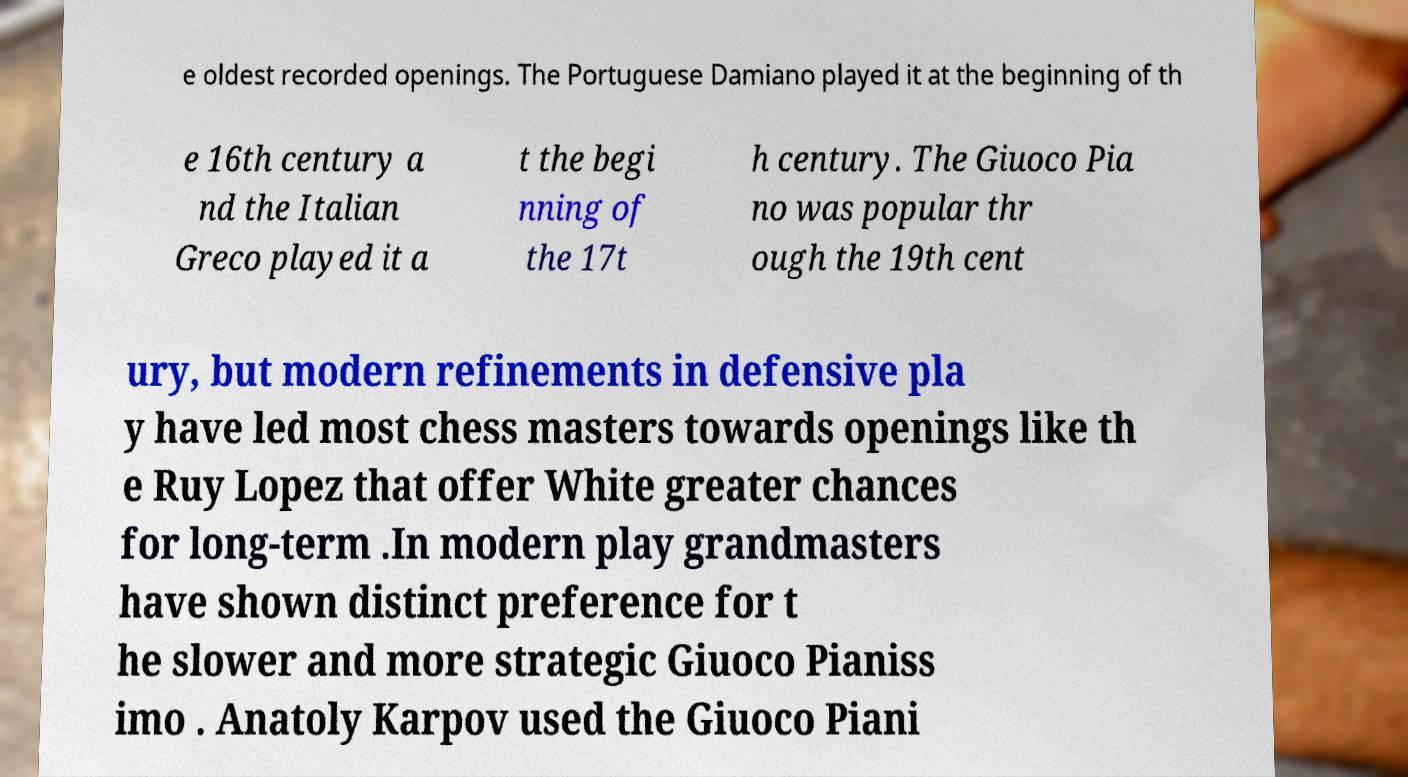Please identify and transcribe the text found in this image. e oldest recorded openings. The Portuguese Damiano played it at the beginning of th e 16th century a nd the Italian Greco played it a t the begi nning of the 17t h century. The Giuoco Pia no was popular thr ough the 19th cent ury, but modern refinements in defensive pla y have led most chess masters towards openings like th e Ruy Lopez that offer White greater chances for long-term .In modern play grandmasters have shown distinct preference for t he slower and more strategic Giuoco Pianiss imo . Anatoly Karpov used the Giuoco Piani 